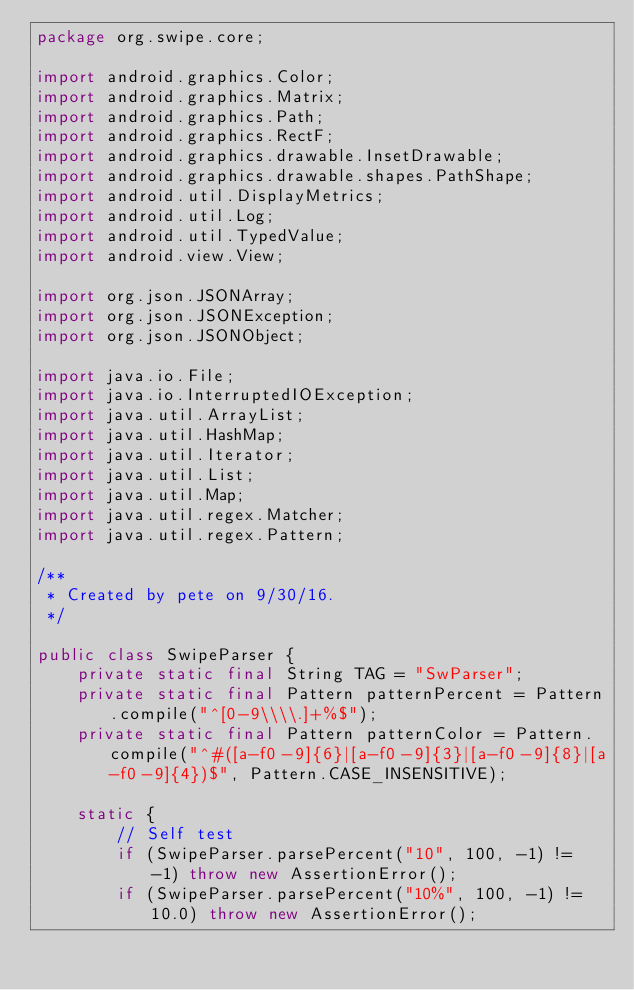Convert code to text. <code><loc_0><loc_0><loc_500><loc_500><_Java_>package org.swipe.core;

import android.graphics.Color;
import android.graphics.Matrix;
import android.graphics.Path;
import android.graphics.RectF;
import android.graphics.drawable.InsetDrawable;
import android.graphics.drawable.shapes.PathShape;
import android.util.DisplayMetrics;
import android.util.Log;
import android.util.TypedValue;
import android.view.View;

import org.json.JSONArray;
import org.json.JSONException;
import org.json.JSONObject;

import java.io.File;
import java.io.InterruptedIOException;
import java.util.ArrayList;
import java.util.HashMap;
import java.util.Iterator;
import java.util.List;
import java.util.Map;
import java.util.regex.Matcher;
import java.util.regex.Pattern;

/**
 * Created by pete on 9/30/16.
 */

public class SwipeParser {
    private static final String TAG = "SwParser";
    private static final Pattern patternPercent = Pattern.compile("^[0-9\\\\.]+%$");
    private static final Pattern patternColor = Pattern.compile("^#([a-f0-9]{6}|[a-f0-9]{3}|[a-f0-9]{8}|[a-f0-9]{4})$", Pattern.CASE_INSENSITIVE);

    static {
        // Self test
        if (SwipeParser.parsePercent("10", 100, -1) != -1) throw new AssertionError();
        if (SwipeParser.parsePercent("10%", 100, -1) != 10.0) throw new AssertionError();</code> 